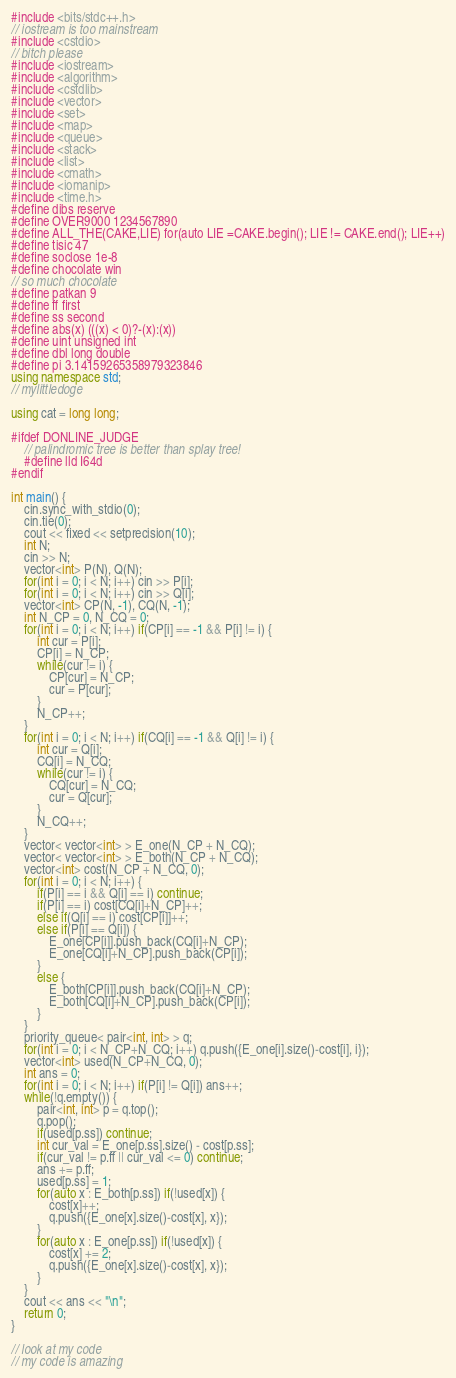Convert code to text. <code><loc_0><loc_0><loc_500><loc_500><_C++_>#include <bits/stdc++.h>
// iostream is too mainstream
#include <cstdio>
// bitch please
#include <iostream>
#include <algorithm>
#include <cstdlib>
#include <vector>
#include <set>
#include <map>
#include <queue>
#include <stack>
#include <list>
#include <cmath>
#include <iomanip>
#include <time.h>
#define dibs reserve
#define OVER9000 1234567890
#define ALL_THE(CAKE,LIE) for(auto LIE =CAKE.begin(); LIE != CAKE.end(); LIE++)
#define tisic 47
#define soclose 1e-8
#define chocolate win
// so much chocolate
#define patkan 9
#define ff first
#define ss second
#define abs(x) (((x) < 0)?-(x):(x))
#define uint unsigned int
#define dbl long double
#define pi 3.14159265358979323846
using namespace std;
// mylittledoge

using cat = long long;

#ifdef DONLINE_JUDGE
	// palindromic tree is better than splay tree!
	#define lld I64d
#endif

int main() {
	cin.sync_with_stdio(0);
	cin.tie(0);
	cout << fixed << setprecision(10);
	int N;
	cin >> N;
	vector<int> P(N), Q(N);
	for(int i = 0; i < N; i++) cin >> P[i];
	for(int i = 0; i < N; i++) cin >> Q[i];
	vector<int> CP(N, -1), CQ(N, -1);
	int N_CP = 0, N_CQ = 0;
	for(int i = 0; i < N; i++) if(CP[i] == -1 && P[i] != i) {
		int cur = P[i];
		CP[i] = N_CP;
		while(cur != i) {
			CP[cur] = N_CP;
			cur = P[cur];
		}
		N_CP++;
	}
	for(int i = 0; i < N; i++) if(CQ[i] == -1 && Q[i] != i) {
		int cur = Q[i];
		CQ[i] = N_CQ;
		while(cur != i) {
			CQ[cur] = N_CQ;
			cur = Q[cur];
		}
		N_CQ++;
	}
	vector< vector<int> > E_one(N_CP + N_CQ);
	vector< vector<int> > E_both(N_CP + N_CQ);
	vector<int> cost(N_CP + N_CQ, 0);
	for(int i = 0; i < N; i++) {
		if(P[i] == i && Q[i] == i) continue;
		if(P[i] == i) cost[CQ[i]+N_CP]++;
		else if(Q[i] == i) cost[CP[i]]++;
		else if(P[i] == Q[i]) {
			E_one[CP[i]].push_back(CQ[i]+N_CP);
			E_one[CQ[i]+N_CP].push_back(CP[i]);
		}
		else {
			E_both[CP[i]].push_back(CQ[i]+N_CP);
			E_both[CQ[i]+N_CP].push_back(CP[i]);
		}
	}
	priority_queue< pair<int, int> > q;
	for(int i = 0; i < N_CP+N_CQ; i++) q.push({E_one[i].size()-cost[i], i});
	vector<int> used(N_CP+N_CQ, 0);
	int ans = 0;
	for(int i = 0; i < N; i++) if(P[i] != Q[i]) ans++;
	while(!q.empty()) {
		pair<int, int> p = q.top();
		q.pop();
		if(used[p.ss]) continue;
		int cur_val = E_one[p.ss].size() - cost[p.ss];
		if(cur_val != p.ff || cur_val <= 0) continue;
		ans += p.ff;
		used[p.ss] = 1;
		for(auto x : E_both[p.ss]) if(!used[x]) {
			cost[x]++;
			q.push({E_one[x].size()-cost[x], x});
		}
		for(auto x : E_one[p.ss]) if(!used[x]) {
			cost[x] += 2;
			q.push({E_one[x].size()-cost[x], x});
		}
	}
	cout << ans << "\n";
	return 0;
}

// look at my code
// my code is amazing
</code> 